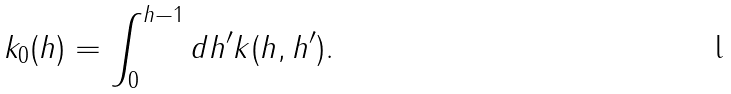Convert formula to latex. <formula><loc_0><loc_0><loc_500><loc_500>k _ { 0 } ( h ) = \int _ { 0 } ^ { h - 1 } d h ^ { \prime } k ( h , h ^ { \prime } ) .</formula> 